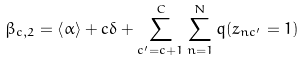Convert formula to latex. <formula><loc_0><loc_0><loc_500><loc_500>\beta _ { c , 2 } = \left < \alpha \right > + c \delta + \sum _ { c ^ { \prime } = c + 1 } ^ { C } \sum _ { n = 1 } ^ { N } q ( z _ { n c ^ { \prime } } = 1 )</formula> 